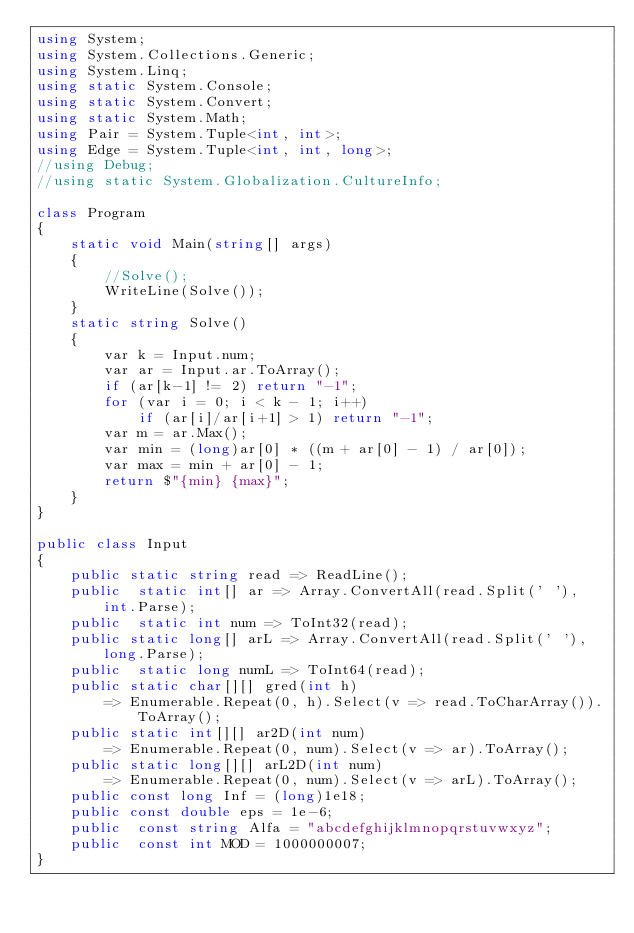<code> <loc_0><loc_0><loc_500><loc_500><_C#_>using System;
using System.Collections.Generic;
using System.Linq;
using static System.Console;
using static System.Convert;
using static System.Math;
using Pair = System.Tuple<int, int>;
using Edge = System.Tuple<int, int, long>;
//using Debug;
//using static System.Globalization.CultureInfo;

class Program
{
    static void Main(string[] args)
    {
        //Solve();
        WriteLine(Solve());
    }
    static string Solve()
    {
        var k = Input.num;
        var ar = Input.ar.ToArray();
        if (ar[k-1] != 2) return "-1";
        for (var i = 0; i < k - 1; i++)
            if (ar[i]/ar[i+1] > 1) return "-1";
        var m = ar.Max();
        var min = (long)ar[0] * ((m + ar[0] - 1) / ar[0]);
        var max = min + ar[0] - 1;
        return $"{min} {max}";
    }
}

public class Input
{
    public static string read => ReadLine();
    public  static int[] ar => Array.ConvertAll(read.Split(' '), int.Parse);
    public  static int num => ToInt32(read);
    public static long[] arL => Array.ConvertAll(read.Split(' '), long.Parse);
    public  static long numL => ToInt64(read);
    public static char[][] gred(int h) 
        => Enumerable.Repeat(0, h).Select(v => read.ToCharArray()).ToArray();
    public static int[][] ar2D(int num)
        => Enumerable.Repeat(0, num).Select(v => ar).ToArray();
    public static long[][] arL2D(int num)
        => Enumerable.Repeat(0, num).Select(v => arL).ToArray();
    public const long Inf = (long)1e18;
    public const double eps = 1e-6;
    public  const string Alfa = "abcdefghijklmnopqrstuvwxyz";
    public  const int MOD = 1000000007;
}
</code> 